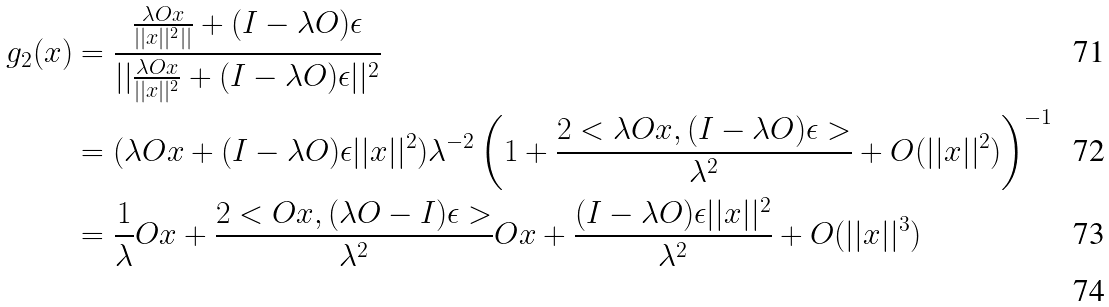<formula> <loc_0><loc_0><loc_500><loc_500>g _ { 2 } ( x ) & = \frac { \frac { \lambda O x } { | | x | | ^ { 2 } | | } + ( I - \lambda O ) \epsilon } { | | \frac { \lambda O x } { | | x | | ^ { 2 } } + ( I - \lambda O ) \epsilon | | ^ { 2 } } \\ & = ( \lambda O x + ( I - \lambda O ) \epsilon | | x | | ^ { 2 } ) \lambda ^ { - 2 } \left ( 1 + \frac { 2 < \lambda O x , ( I - \lambda O ) \epsilon > } { \lambda ^ { 2 } } + O ( | | x | | ^ { 2 } ) \right ) ^ { - 1 } \\ & = \frac { 1 } { \lambda } O x + \frac { 2 < O x , ( \lambda O - I ) \epsilon > } { \lambda ^ { 2 } } O x + \frac { ( I - \lambda O ) \epsilon | | x | | ^ { 2 } } { \lambda ^ { 2 } } + O ( | | x | | ^ { 3 } ) \\</formula> 